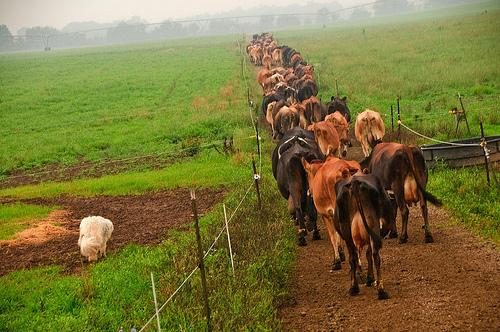What is the general condition of the pasture in the image? The pasture is green and thick, with some areas of mud in the grass. What objects or features are present in the far background and atmosphere of the image? Trees can be seen on the horizon in the far background, and the atmosphere is foggy. What type of surface is the cow walking on, and what are its notable features? The cows are walking on a brown dirt pathway which has fences on both sides. Which other animals can be found in the image apart from the cows? A furry white dog and sheep can be found in the image apart from the cows. What part of a cow is highlighted in the image, and where is it located? The udder of a cow is highlighted, located near the central part of the image. Where is the metal fence located in relation to the main group of animals? The metal fence is located to the left of the cows, running along the boundary of the pasture. Identify and describe a supplementary object in the image apart from animals. A large metal tub is present in the image with its circular shape and gray color. Provide a detailed description of the main object in the top-left area of the image. A furry white dog is sniffing the grass in a field, with its head down and body slightly tilted. Describe the water trough's position and appearance in relation to the animals. The water trough is round and located to the right of the cows in the pasture. From the image, what type of animals is present in the majority? A large herd of cattle, including black and brown cows with full utters, dominates the majority of the image. Find the group of pigs in the mud near the fence. There is no mention of pigs in the image's captions. The instruction is misleading because it asks the viewer to locate an object (group of pigs) that is not present in the image. Which tree is the bird perched on in the background? No, it's not mentioned in the image. Find the large group of chickens in the field of grass. There is no mention of chickens in the image's captions. The instruction is misleading because it asks the viewer to identify an object (group of chickens) that is not present in the image. Do you see any people riding bicycles along the dirt cow path? There is no mention of people or bicycles in the image's captions. The instruction is misleading as it asks the viewer to identify objects (people, bicycles) and actions (riding) that are not present in the image. Can you see the rainbow in the sky above the fog on the horizon? There is no mention of a rainbow in the image's captions. The instruction is misleading as it asks the viewer to find an object (rainbow) that is not present in the image. Can you see the red dog playing with a ball in the grass? There is no red dog or ball mentioned in the image's captions. The instruction is misleading as it mentions an object (red dog) and an action (playing with a ball) that are not present in the image. Look for the horse standing next to the water trough. The image does not contain any information about a horse. The instruction is misleading as it asks the viewer to find an object (horse) that is not present in the image. Notice how the zebra is hiding among the trees in the background. There is no mention of a zebra in the image's captions. The instruction is misleading as it asks the viewer to identify an object (zebra) that is not present in the image. Spot the cat sitting on top of the metal fence. There is no mention of a cat in the image's captions. The instruction is misleading as it asks the viewer to locate an object (cat) that is not present in the image. Observe how cows are flying over the field of grass. The image's captions describe cows walking, not flying. The instruction is misleading as it suggests an unrealistic action (flying cows) that is not depicted in the image. Notice the tractor working in the field near the line of cows. There is no mention of a tractor in the image's captions. The instruction is misleading because it asks the viewer to locate an object (tractor) that is not present in the image. 